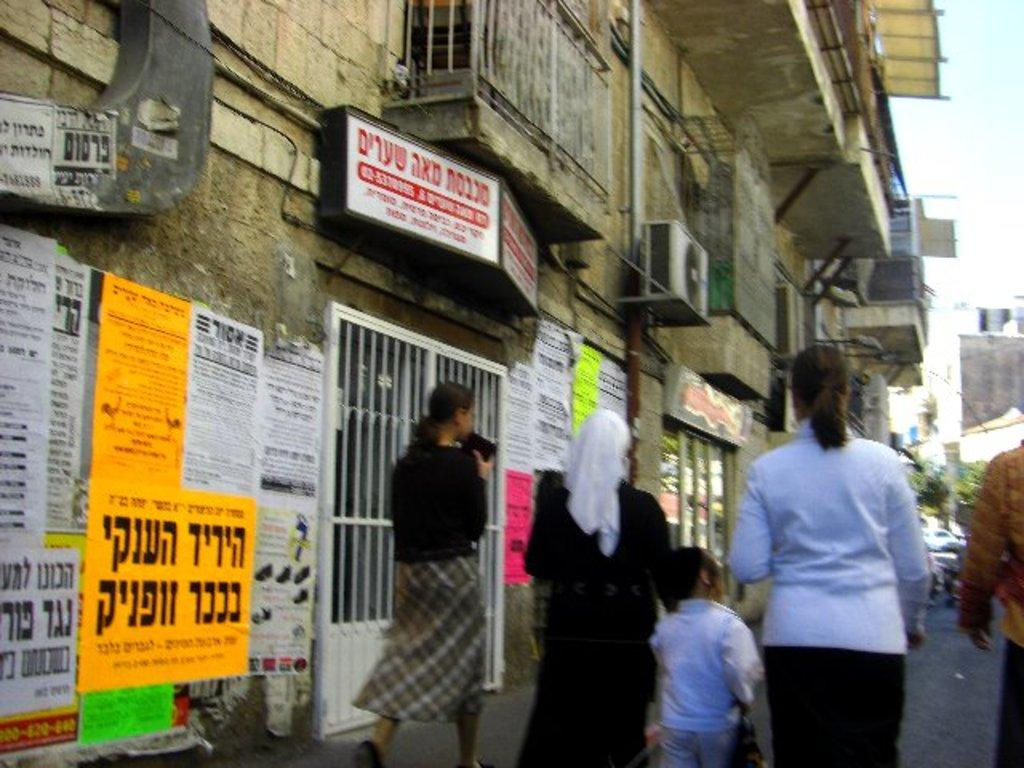What is happening on the ground in the image? There are people on the ground in the image. What can be seen in the distance behind the people? There are buildings visible in the background of the image. What is visible above the buildings in the image? The sky is visible in the background of the image. What is attached to the wall in the image? There are posters and other objects attached to the wall in the image. What season is it in the image, considering the presence of winter or summer? The provided facts do not mention any seasonal elements, so it is impossible to determine if it is winter or summer in the image. What type of knowledge is being shared through the posters in the image? The provided facts do not mention the content of the posters, so it is impossible to determine what type of knowledge is being shared. 